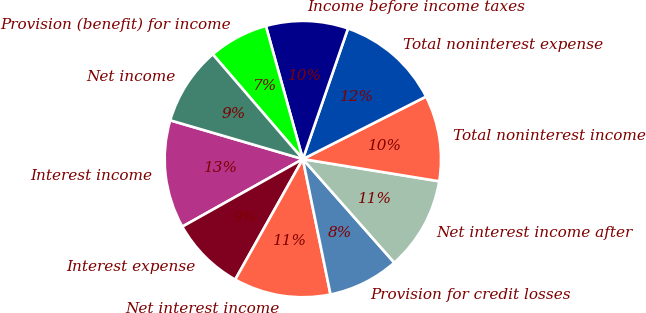Convert chart to OTSL. <chart><loc_0><loc_0><loc_500><loc_500><pie_chart><fcel>Interest income<fcel>Interest expense<fcel>Net interest income<fcel>Provision for credit losses<fcel>Net interest income after<fcel>Total noninterest income<fcel>Total noninterest expense<fcel>Income before income taxes<fcel>Provision (benefit) for income<fcel>Net income<nl><fcel>12.66%<fcel>8.73%<fcel>11.35%<fcel>8.3%<fcel>10.92%<fcel>10.04%<fcel>12.23%<fcel>9.61%<fcel>6.99%<fcel>9.17%<nl></chart> 